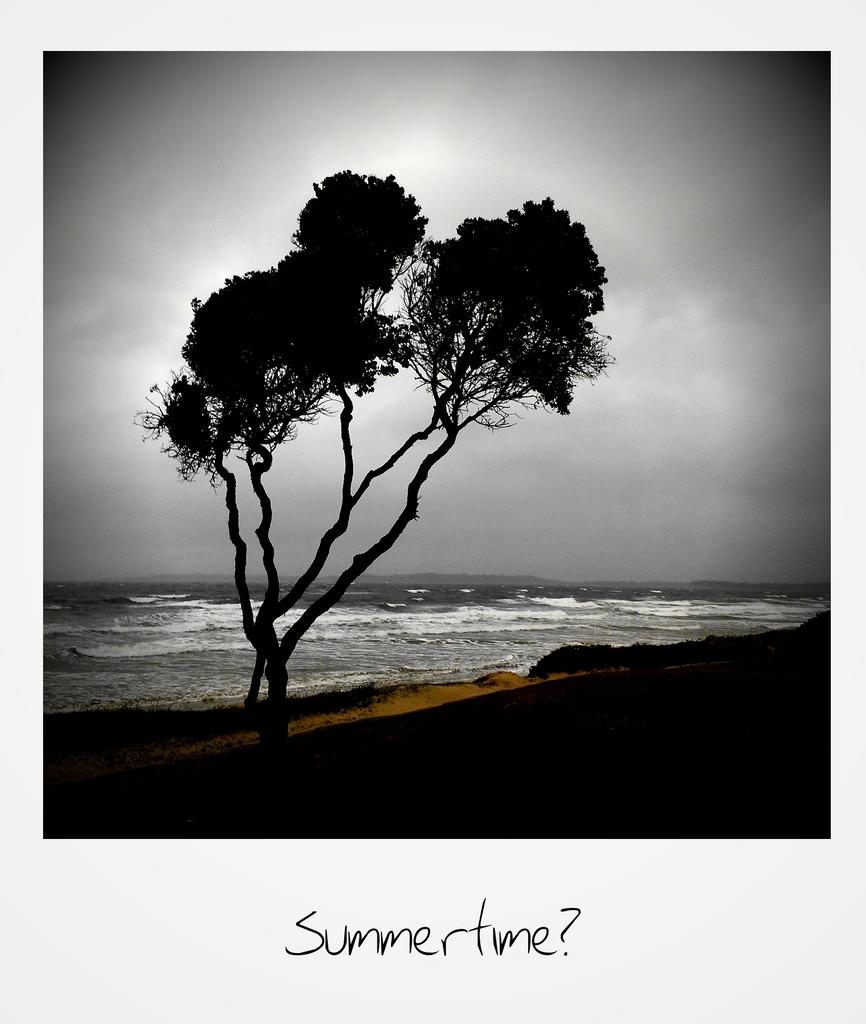What is located in the middle of the image? There are trees in the middle of the image. What can be seen in the background of the image? There is water visible in the background of the image. What is present at the bottom of the image? There is text at the bottom of the image. What is visible at the top of the image? The sky is visible at the top of the image. What is the condition of the sky in the image? The sky appears to be cloudy. How many servants are visible in the image? There are no servants present in the image. What type of chin can be seen on the trees in the image? There are no chins present in the image, as it features trees and a cloudy sky. 